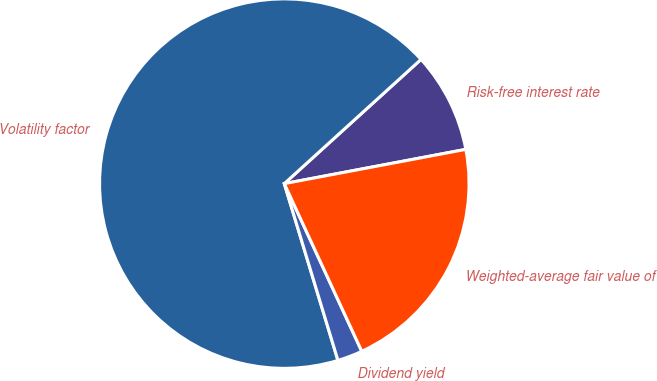Convert chart. <chart><loc_0><loc_0><loc_500><loc_500><pie_chart><fcel>Risk-free interest rate<fcel>Volatility factor<fcel>Dividend yield<fcel>Weighted-average fair value of<nl><fcel>8.77%<fcel>67.95%<fcel>2.2%<fcel>21.08%<nl></chart> 